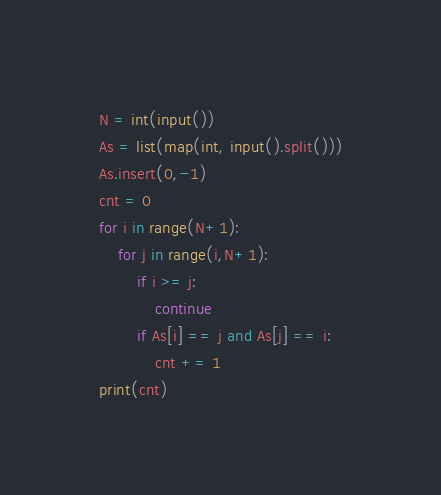Convert code to text. <code><loc_0><loc_0><loc_500><loc_500><_Python_>N = int(input())
As = list(map(int, input().split()))
As.insert(0,-1)
cnt = 0
for i in range(N+1):
    for j in range(i,N+1):
        if i >= j:
            continue
        if As[i] == j and As[j] == i:
            cnt += 1
print(cnt)
</code> 